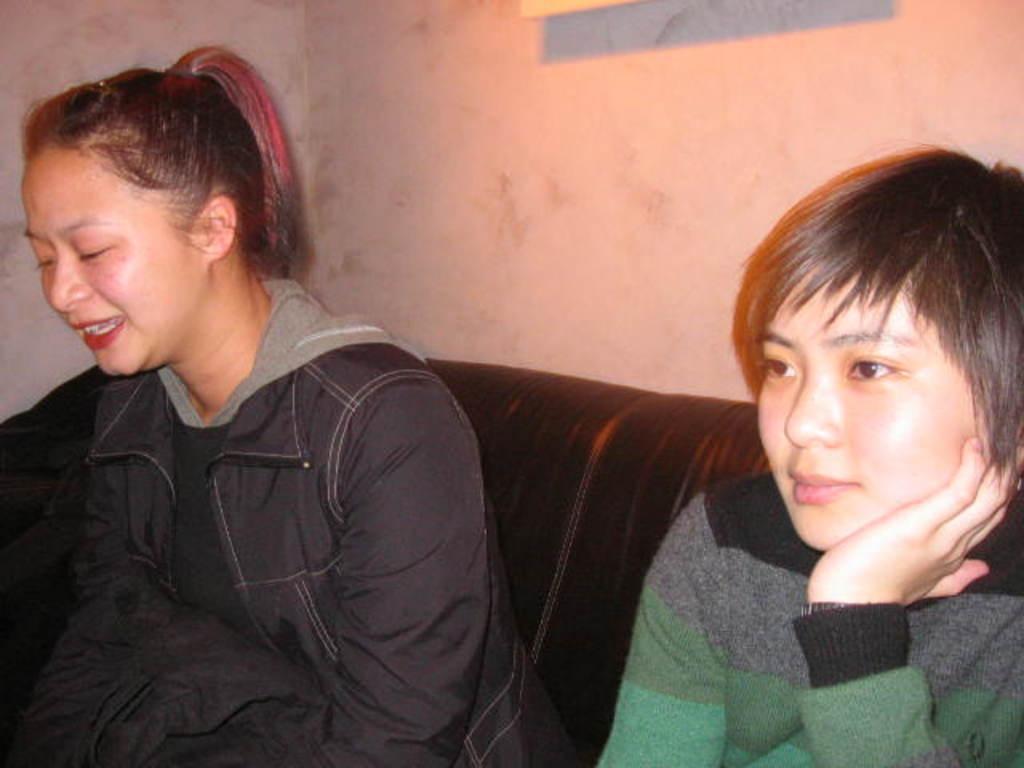Please provide a concise description of this image. In this image there are two women who are sitting on a couch and there is a wall, at the top there is some object. 